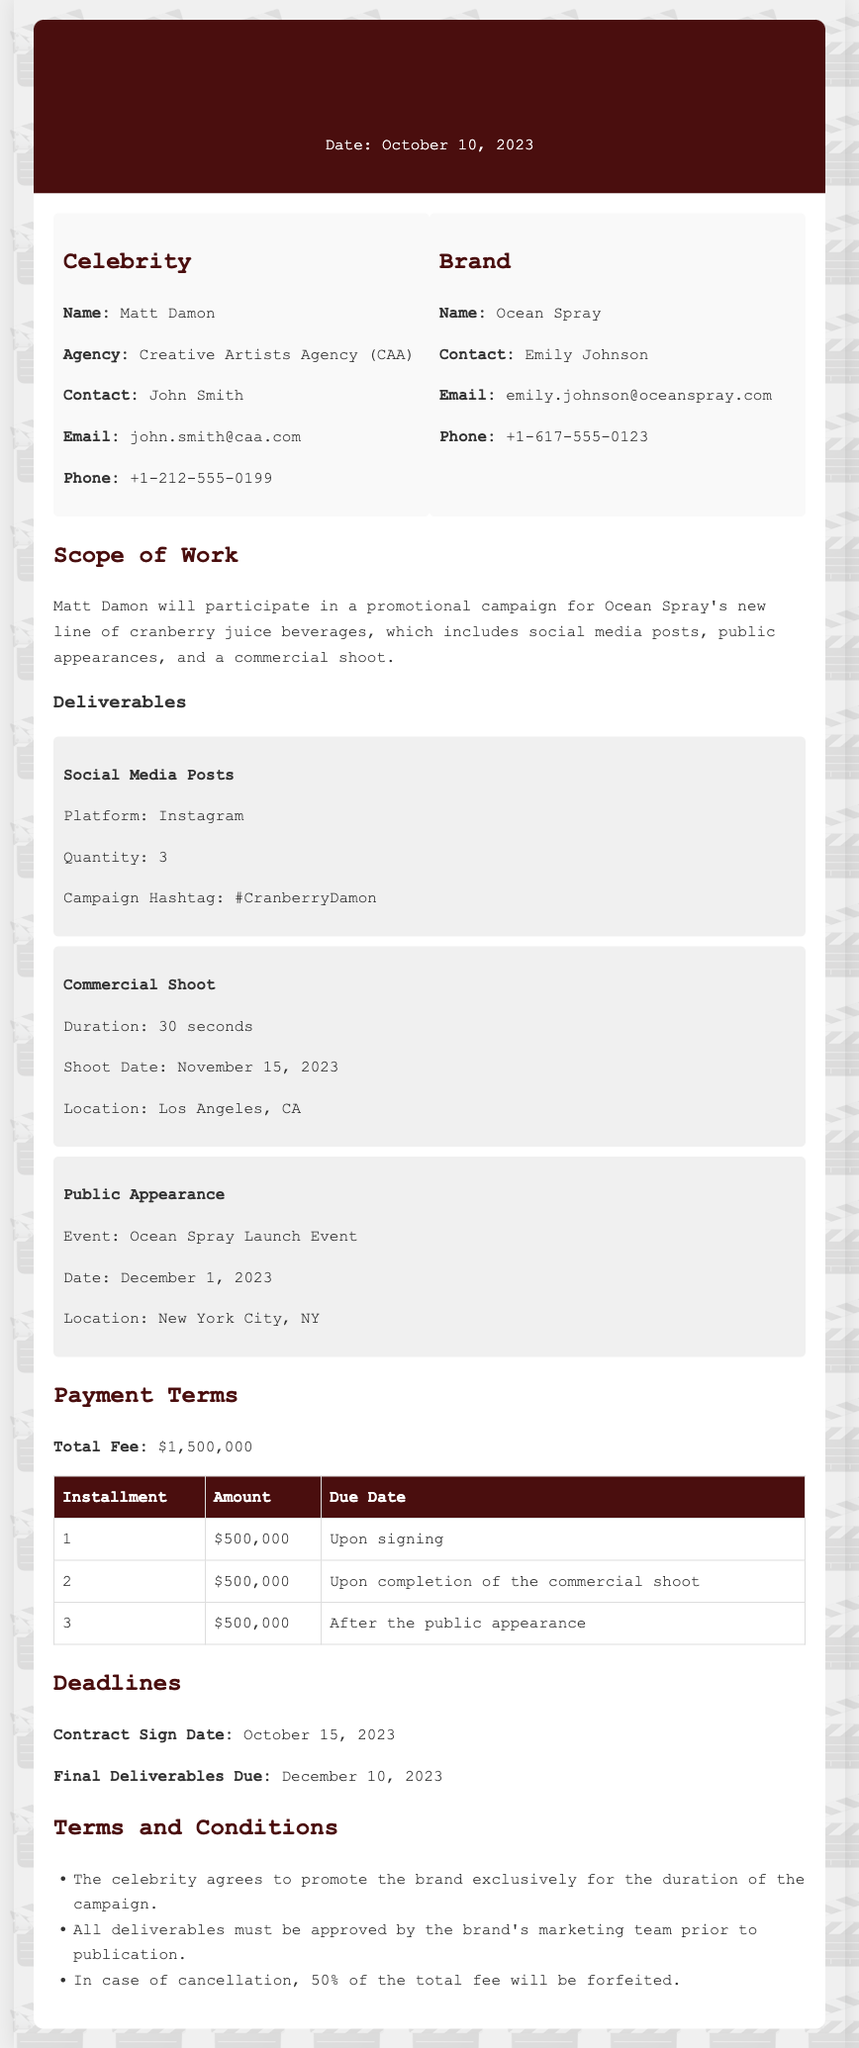What is the total fee? The total fee is listed in the payment terms section, which is $1,500,000.
Answer: $1,500,000 When does the commercial shoot take place? The date for the commercial shoot can be found in the deliverables section, which specifies November 15, 2023.
Answer: November 15, 2023 Who is the contact person for the brand? The contact person for the brand, Ocean Spray, is mentioned in the brand section as Emily Johnson.
Answer: Emily Johnson How many social media posts are required? The quantity of social media posts is stated in the deliverables section, which specifies 3 posts.
Answer: 3 What percentage of the total fee is forfeited in case of cancellation? The terms and conditions state that in case of cancellation, 50% of the total fee will be forfeited.
Answer: 50% What is the contract sign date? The contract sign date is mentioned in the deadlines section as October 15, 2023.
Answer: October 15, 2023 What is the event associated with the public appearance? The event for the public appearance is specified in the deliverables section as the Ocean Spray Launch Event.
Answer: Ocean Spray Launch Event How many installments are specified for the payment? The payment terms outline that there are 3 installments to be paid.
Answer: 3 What is the required location for the commercial shoot? The location for the commercial shoot is specified in the deliverables section as Los Angeles, CA.
Answer: Los Angeles, CA 